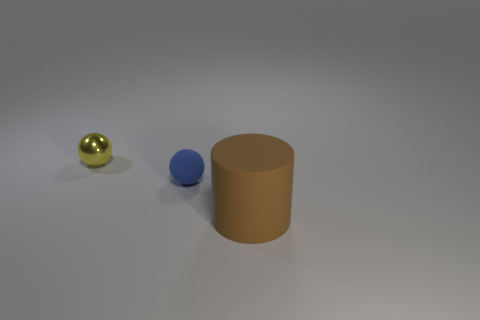Add 1 big brown rubber cylinders. How many objects exist? 4 Subtract all cylinders. How many objects are left? 2 Add 2 tiny blue spheres. How many tiny blue spheres exist? 3 Subtract 0 green balls. How many objects are left? 3 Subtract all tiny blue balls. Subtract all small cyan metallic objects. How many objects are left? 2 Add 1 metal things. How many metal things are left? 2 